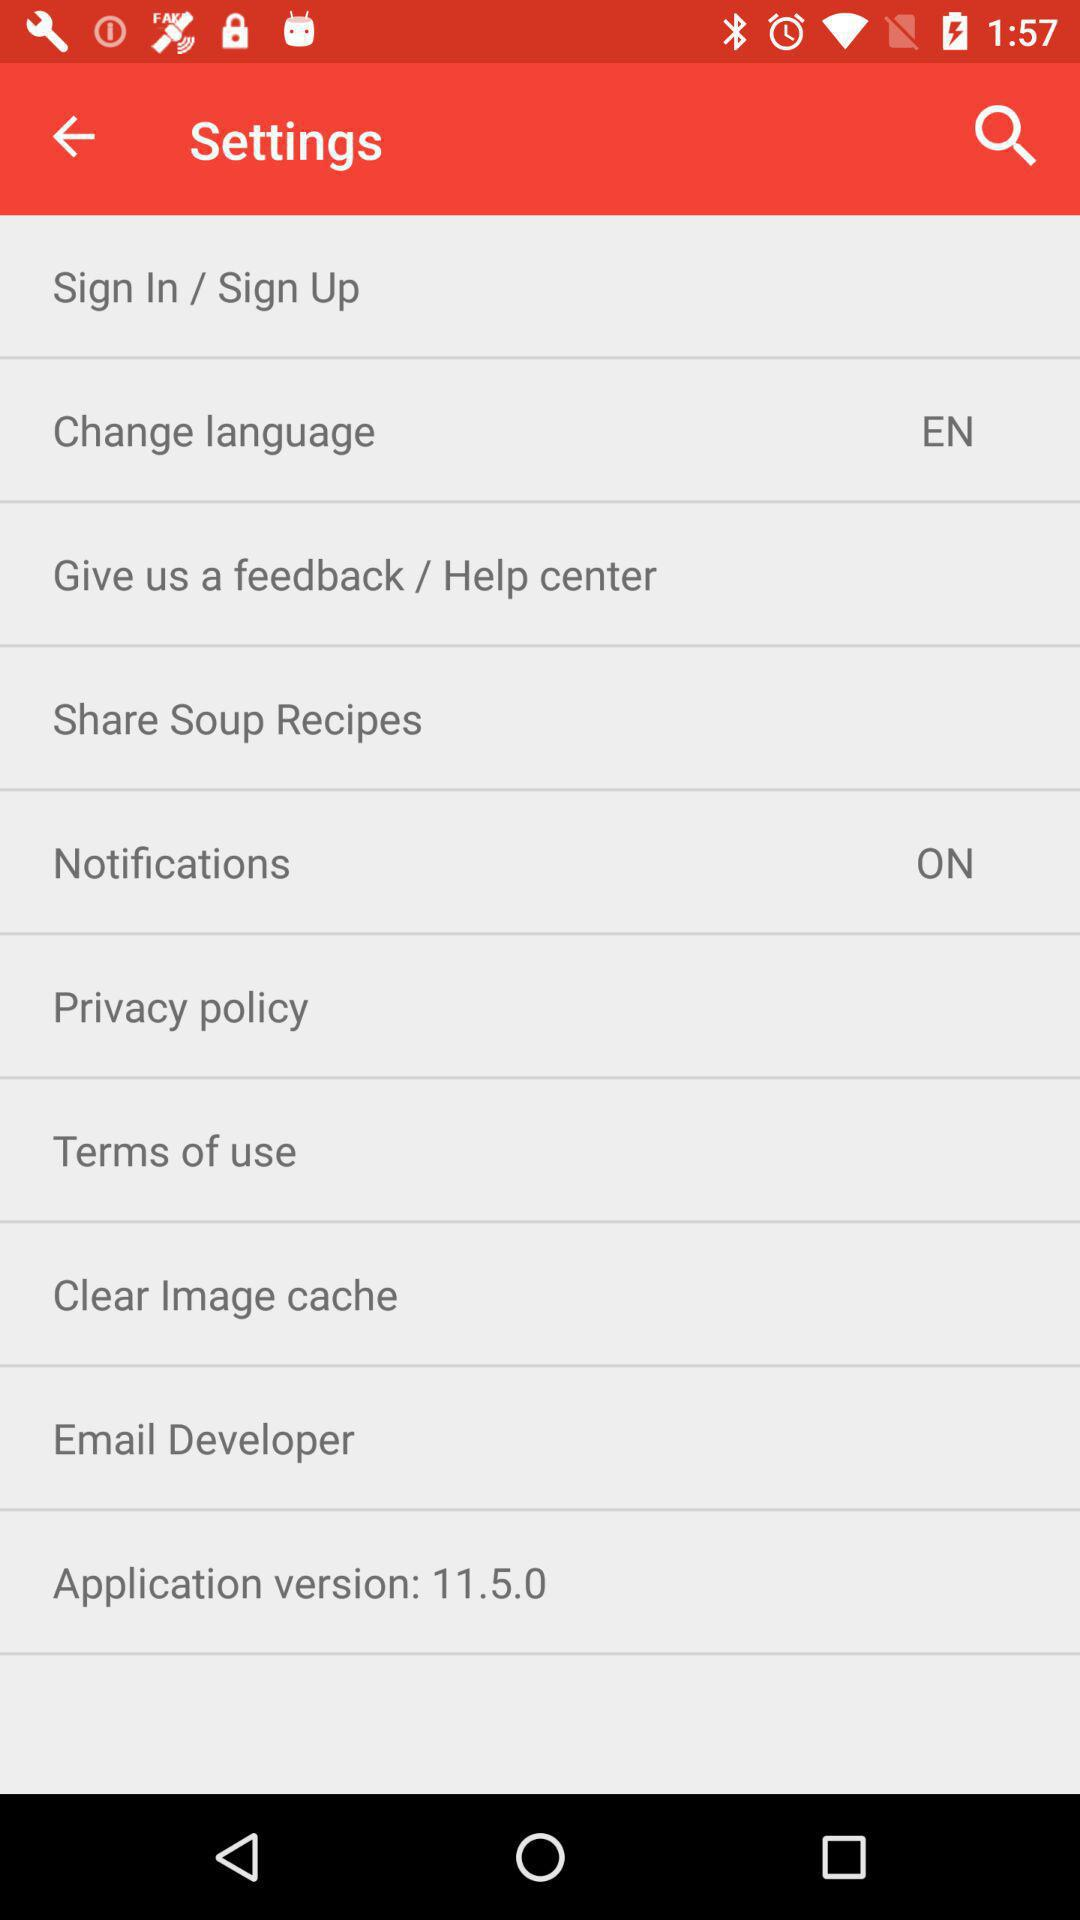What is the setting for the "Notifications"? The setting is "on". 